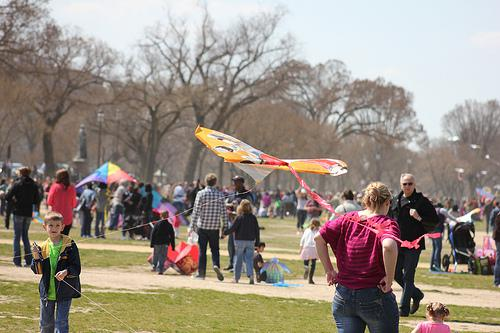Question: who is wearing a green shirt?
Choices:
A. A girl.
B. Person on right.
C. A boy.
D. Person in back.
Answer with the letter. Answer: C Question: what color is the nearest kite?
Choices:
A. Yellow.
B. Purple.
C. Orange.
D. Green.
Answer with the letter. Answer: C Question: what color is the sky?
Choices:
A. Blue.
B. White.
C. Gray.
D. Yellow.
Answer with the letter. Answer: A Question: where is the orange kite?
Choices:
A. Flying.
B. Over the trees.
C. In the air.
D. On the ground.
Answer with the letter. Answer: C 